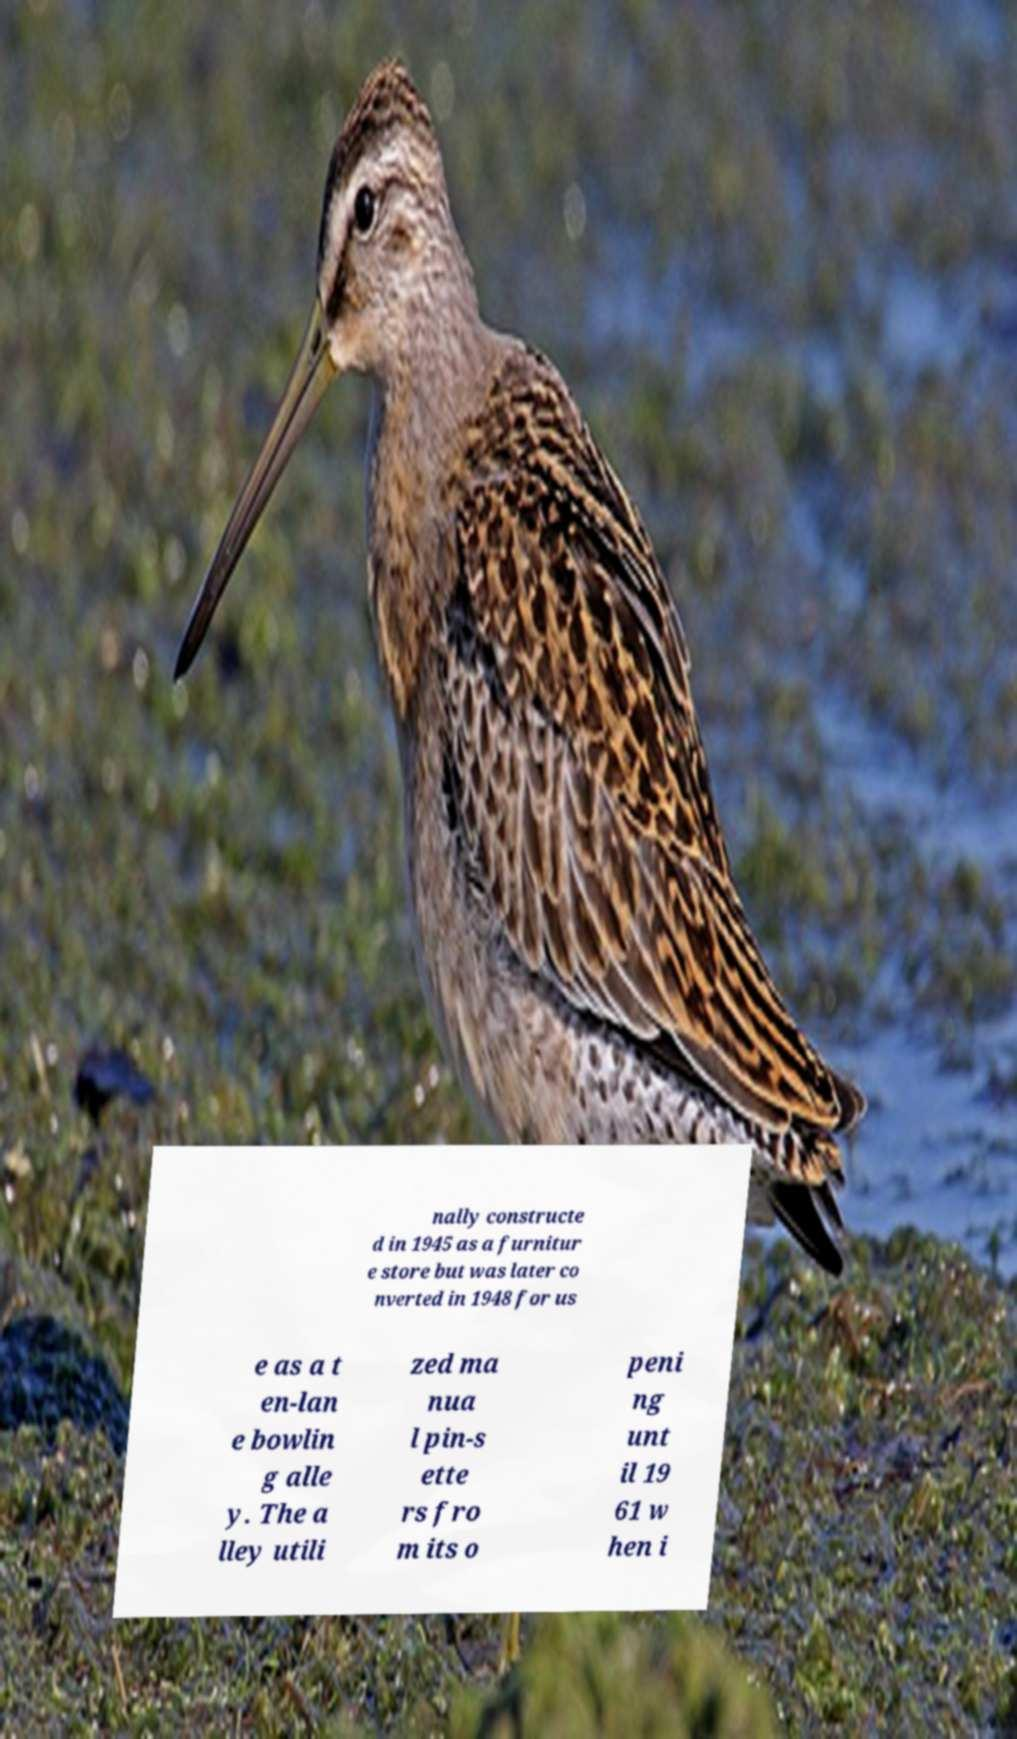Please identify and transcribe the text found in this image. nally constructe d in 1945 as a furnitur e store but was later co nverted in 1948 for us e as a t en-lan e bowlin g alle y. The a lley utili zed ma nua l pin-s ette rs fro m its o peni ng unt il 19 61 w hen i 